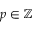<formula> <loc_0><loc_0><loc_500><loc_500>p \in \mathbb { Z }</formula> 